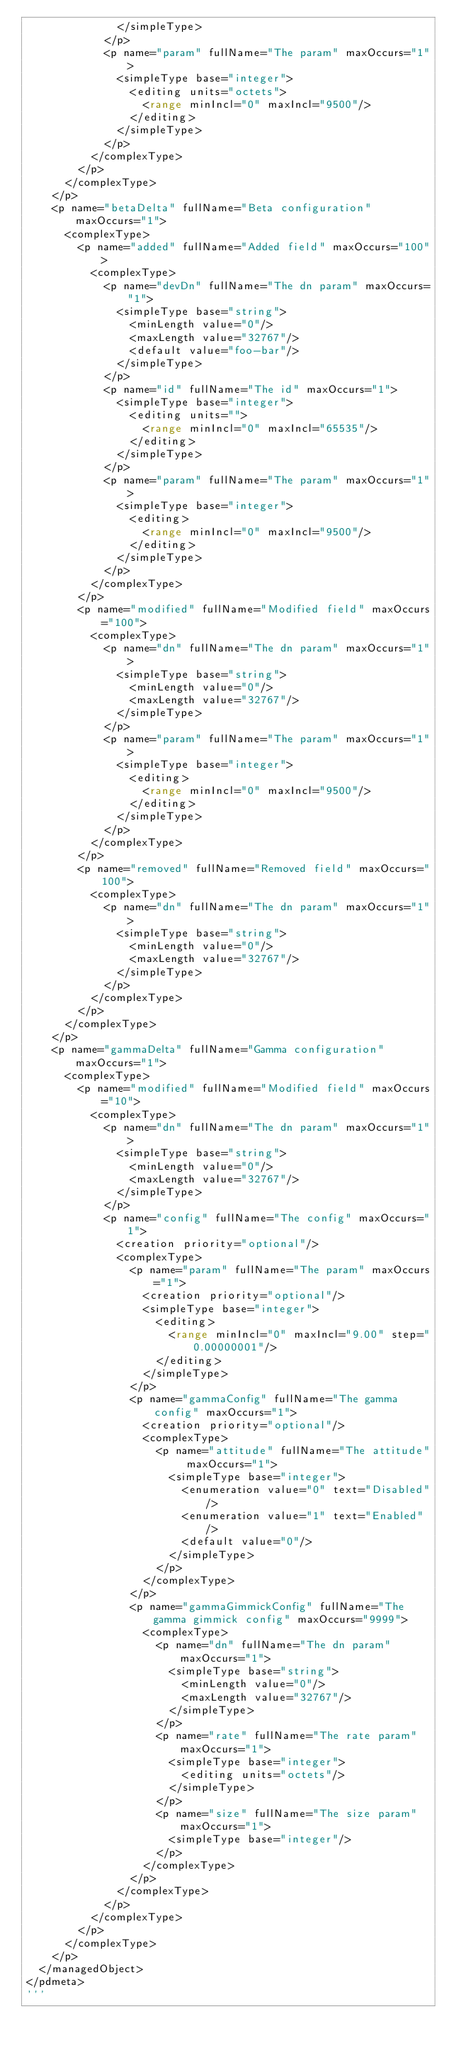<code> <loc_0><loc_0><loc_500><loc_500><_Python_>              </simpleType>
            </p>
            <p name="param" fullName="The param" maxOccurs="1">
              <simpleType base="integer">
                <editing units="octets">
                  <range minIncl="0" maxIncl="9500"/>
                </editing>
              </simpleType>
            </p>
          </complexType>
        </p>
      </complexType>
    </p>
    <p name="betaDelta" fullName="Beta configuration" maxOccurs="1">
      <complexType>
        <p name="added" fullName="Added field" maxOccurs="100">
          <complexType>
            <p name="devDn" fullName="The dn param" maxOccurs="1">
              <simpleType base="string">
                <minLength value="0"/>
                <maxLength value="32767"/>
                <default value="foo-bar"/>
              </simpleType>
            </p>
            <p name="id" fullName="The id" maxOccurs="1">
              <simpleType base="integer">
                <editing units="">
                  <range minIncl="0" maxIncl="65535"/>
                </editing>
              </simpleType>
            </p>
            <p name="param" fullName="The param" maxOccurs="1">
              <simpleType base="integer">
                <editing>
                  <range minIncl="0" maxIncl="9500"/>
                </editing>
              </simpleType>
            </p>
          </complexType>
        </p>
        <p name="modified" fullName="Modified field" maxOccurs="100">
          <complexType>
            <p name="dn" fullName="The dn param" maxOccurs="1">
              <simpleType base="string">
                <minLength value="0"/>
                <maxLength value="32767"/>
              </simpleType>
            </p>
            <p name="param" fullName="The param" maxOccurs="1">
              <simpleType base="integer">
                <editing>
                  <range minIncl="0" maxIncl="9500"/>
                </editing>
              </simpleType>
            </p>
          </complexType>
        </p>
        <p name="removed" fullName="Removed field" maxOccurs="100">
          <complexType>
            <p name="dn" fullName="The dn param" maxOccurs="1">
              <simpleType base="string">
                <minLength value="0"/>
                <maxLength value="32767"/>
              </simpleType>
            </p>
          </complexType>
        </p>
      </complexType>
    </p>
    <p name="gammaDelta" fullName="Gamma configuration" maxOccurs="1">
      <complexType>
        <p name="modified" fullName="Modified field" maxOccurs="10">
          <complexType>
            <p name="dn" fullName="The dn param" maxOccurs="1">
              <simpleType base="string">
                <minLength value="0"/>
                <maxLength value="32767"/>
              </simpleType>
            </p>
            <p name="config" fullName="The config" maxOccurs="1">
              <creation priority="optional"/>
              <complexType>
                <p name="param" fullName="The param" maxOccurs="1">
                  <creation priority="optional"/>
                  <simpleType base="integer">
                    <editing>
                      <range minIncl="0" maxIncl="9.00" step="0.00000001"/>
                    </editing>
                  </simpleType>
                </p>
                <p name="gammaConfig" fullName="The gamma config" maxOccurs="1">
                  <creation priority="optional"/>
                  <complexType>
                    <p name="attitude" fullName="The attitude" maxOccurs="1">
                      <simpleType base="integer">
                        <enumeration value="0" text="Disabled"/>
                        <enumeration value="1" text="Enabled"/>
                        <default value="0"/>
                      </simpleType>
                    </p>
                  </complexType>
                </p>
                <p name="gammaGimmickConfig" fullName="The gamma gimmick config" maxOccurs="9999">
                  <complexType>
                    <p name="dn" fullName="The dn param" maxOccurs="1">
                      <simpleType base="string">
                        <minLength value="0"/>
                        <maxLength value="32767"/>
                      </simpleType>
                    </p>
                    <p name="rate" fullName="The rate param" maxOccurs="1">
                      <simpleType base="integer">
                        <editing units="octets"/>
                      </simpleType>
                    </p>
                    <p name="size" fullName="The size param" maxOccurs="1">
                      <simpleType base="integer"/>
                    </p>
                  </complexType>
                </p>
              </complexType>
            </p>
          </complexType>
        </p>
      </complexType>
    </p>
  </managedObject>
</pdmeta>
'''
</code> 